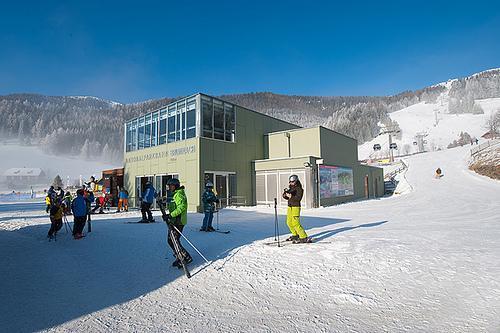How many skiers are on the bottom turn of the trail?
Give a very brief answer. 4. 